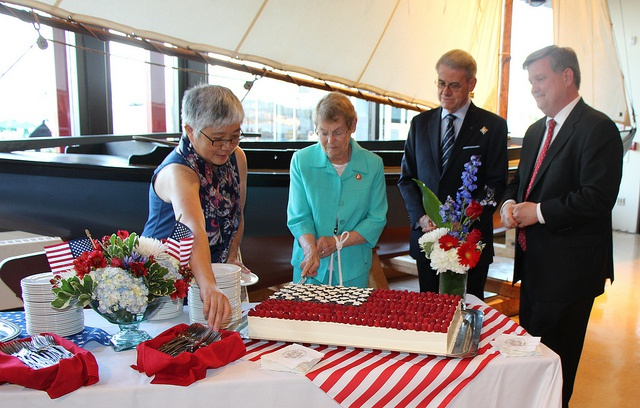Describe the objects in this image and their specific colors. I can see boat in gray, beige, black, and darkblue tones, dining table in gray, lightgray, brown, darkgray, and maroon tones, people in gray, black, darkgray, brown, and lightgray tones, people in gray, teal, and brown tones, and people in gray, brown, black, and lightgray tones in this image. 